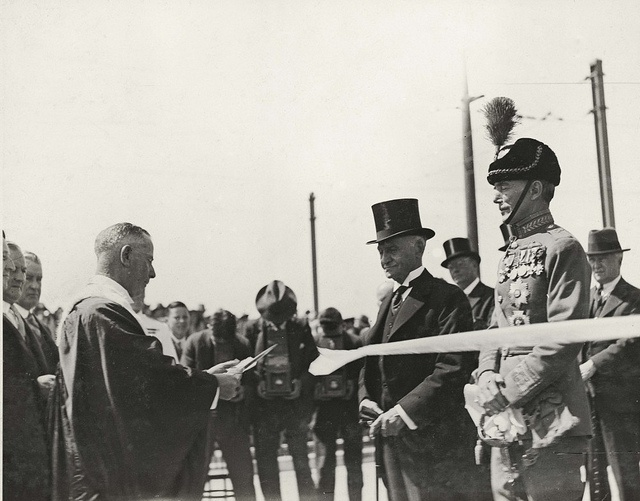Describe the objects in this image and their specific colors. I can see people in lightgray, gray, black, and darkgray tones, people in lightgray, black, gray, and darkgray tones, people in lightgray, black, gray, and darkgray tones, people in lightgray, black, gray, and darkgray tones, and people in lightgray, black, gray, and darkgray tones in this image. 